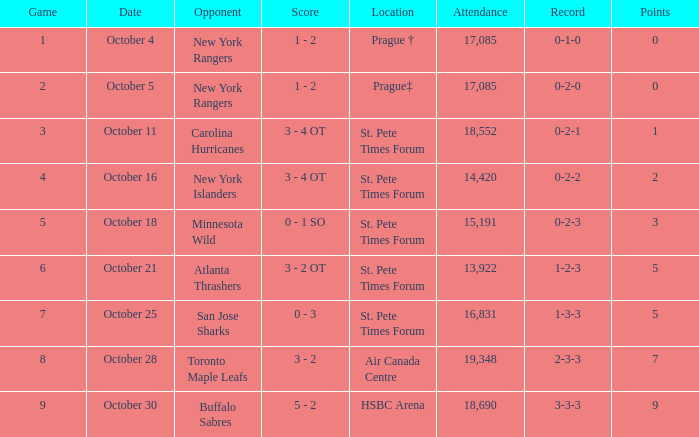What was the attendance when their record stood at 0-2-2? 14420.0. 